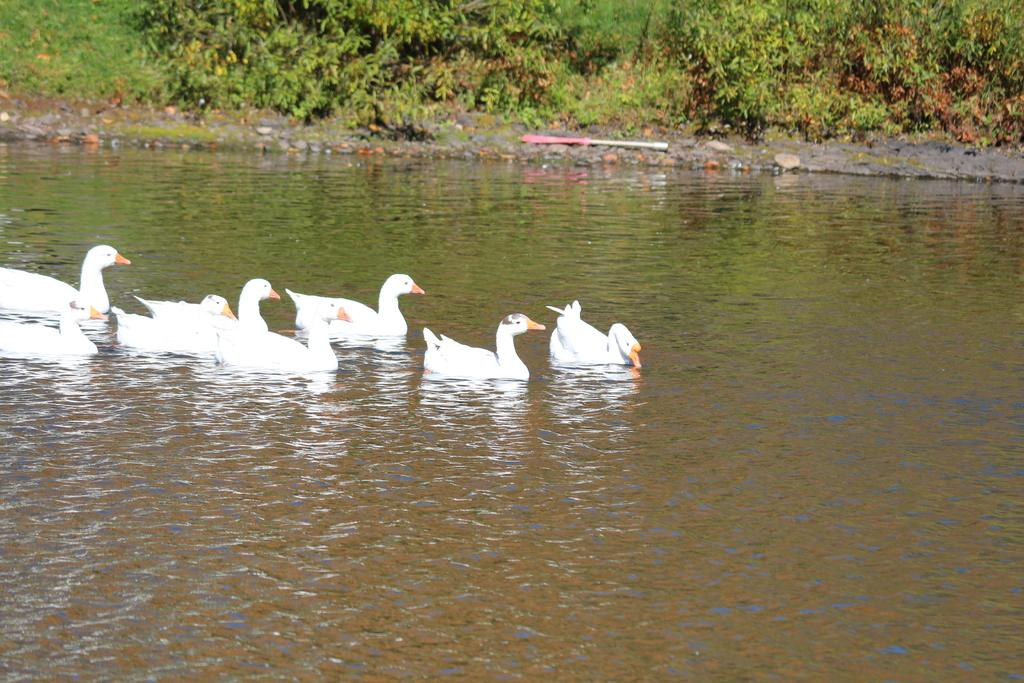What type of animals are in the image? There are white ducks in the image. Where are the ducks located? The ducks are in the water. What can be seen in the background of the image? There are trees visible in the image. What type of yam is being used as a toy by the sheep in the image? A: There are no sheep or yams present in the image; it features white ducks in the water with trees in the background. 